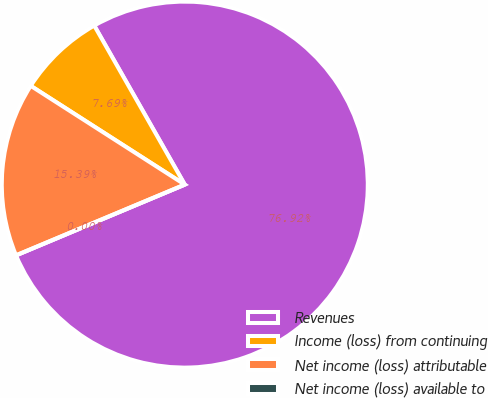Convert chart to OTSL. <chart><loc_0><loc_0><loc_500><loc_500><pie_chart><fcel>Revenues<fcel>Income (loss) from continuing<fcel>Net income (loss) attributable<fcel>Net income (loss) available to<nl><fcel>76.92%<fcel>7.69%<fcel>15.39%<fcel>0.0%<nl></chart> 